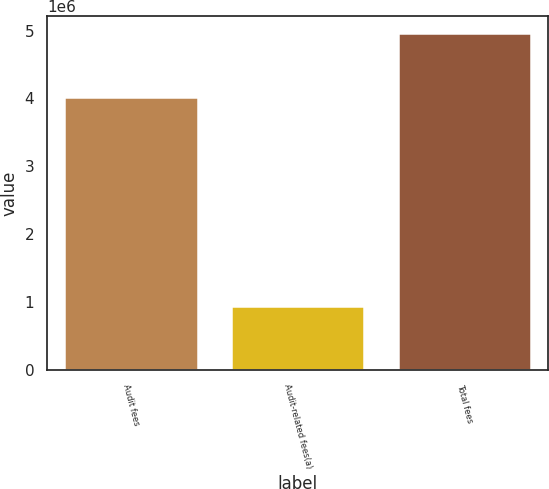Convert chart. <chart><loc_0><loc_0><loc_500><loc_500><bar_chart><fcel>Audit fees<fcel>Audit-related fees(a)<fcel>Total fees<nl><fcel>4.02176e+06<fcel>939742<fcel>4.9615e+06<nl></chart> 